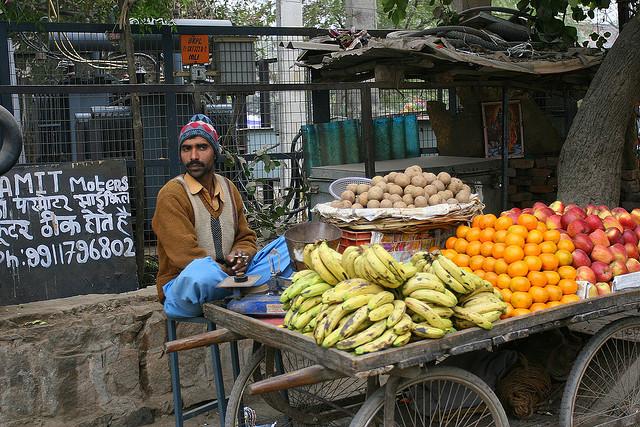How many types of fruit is this man selling?
Give a very brief answer. 4. Is the sign in English?
Concise answer only. No. Is the man sitting with his legs crossed?
Short answer required. Yes. 